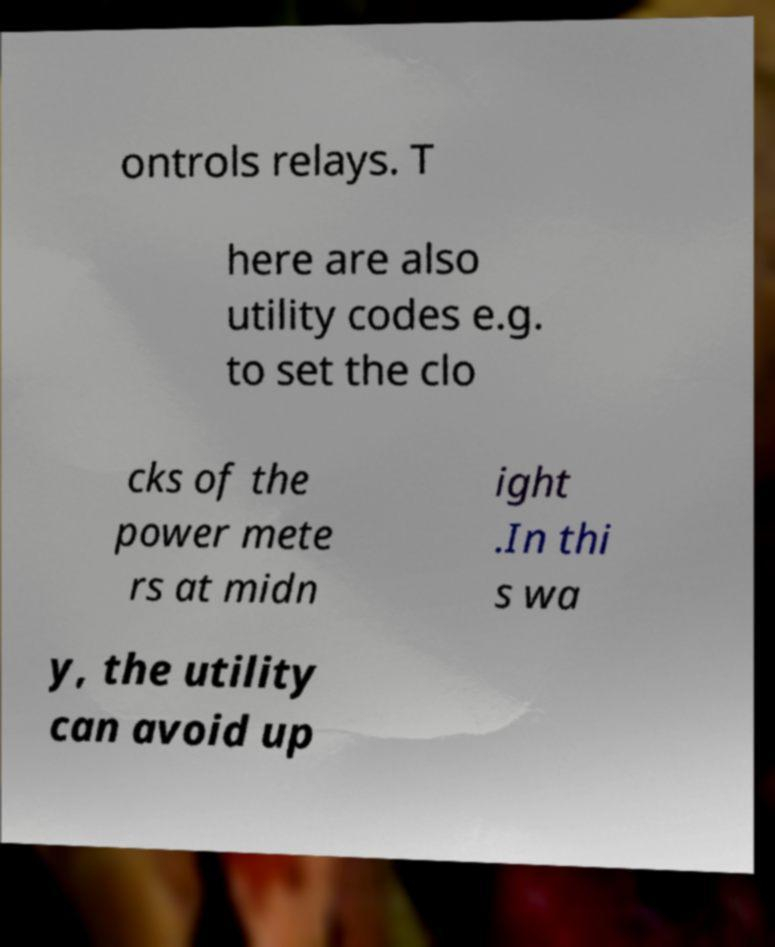There's text embedded in this image that I need extracted. Can you transcribe it verbatim? ontrols relays. T here are also utility codes e.g. to set the clo cks of the power mete rs at midn ight .In thi s wa y, the utility can avoid up 